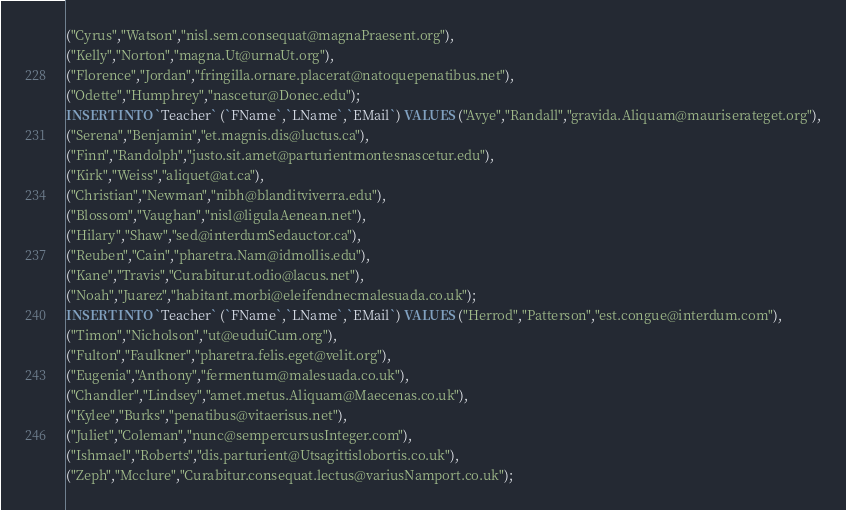<code> <loc_0><loc_0><loc_500><loc_500><_SQL_>("Cyrus","Watson","nisl.sem.consequat@magnaPraesent.org"),
("Kelly","Norton","magna.Ut@urnaUt.org"),
("Florence","Jordan","fringilla.ornare.placerat@natoquepenatibus.net"),
("Odette","Humphrey","nascetur@Donec.edu");
INSERT INTO `Teacher` (`FName`,`LName`,`EMail`) VALUES ("Avye","Randall","gravida.Aliquam@mauriserateget.org"),
("Serena","Benjamin","et.magnis.dis@luctus.ca"),
("Finn","Randolph","justo.sit.amet@parturientmontesnascetur.edu"),
("Kirk","Weiss","aliquet@at.ca"),
("Christian","Newman","nibh@blanditviverra.edu"),
("Blossom","Vaughan","nisl@ligulaAenean.net"),
("Hilary","Shaw","sed@interdumSedauctor.ca"),
("Reuben","Cain","pharetra.Nam@idmollis.edu"),
("Kane","Travis","Curabitur.ut.odio@lacus.net"),
("Noah","Juarez","habitant.morbi@eleifendnecmalesuada.co.uk");
INSERT INTO `Teacher` (`FName`,`LName`,`EMail`) VALUES ("Herrod","Patterson","est.congue@interdum.com"),
("Timon","Nicholson","ut@euduiCum.org"),
("Fulton","Faulkner","pharetra.felis.eget@velit.org"),
("Eugenia","Anthony","fermentum@malesuada.co.uk"),
("Chandler","Lindsey","amet.metus.Aliquam@Maecenas.co.uk"),
("Kylee","Burks","penatibus@vitaerisus.net"),
("Juliet","Coleman","nunc@sempercursusInteger.com"),
("Ishmael","Roberts","dis.parturient@Utsagittislobortis.co.uk"),
("Zeph","Mcclure","Curabitur.consequat.lectus@variusNamport.co.uk");</code> 